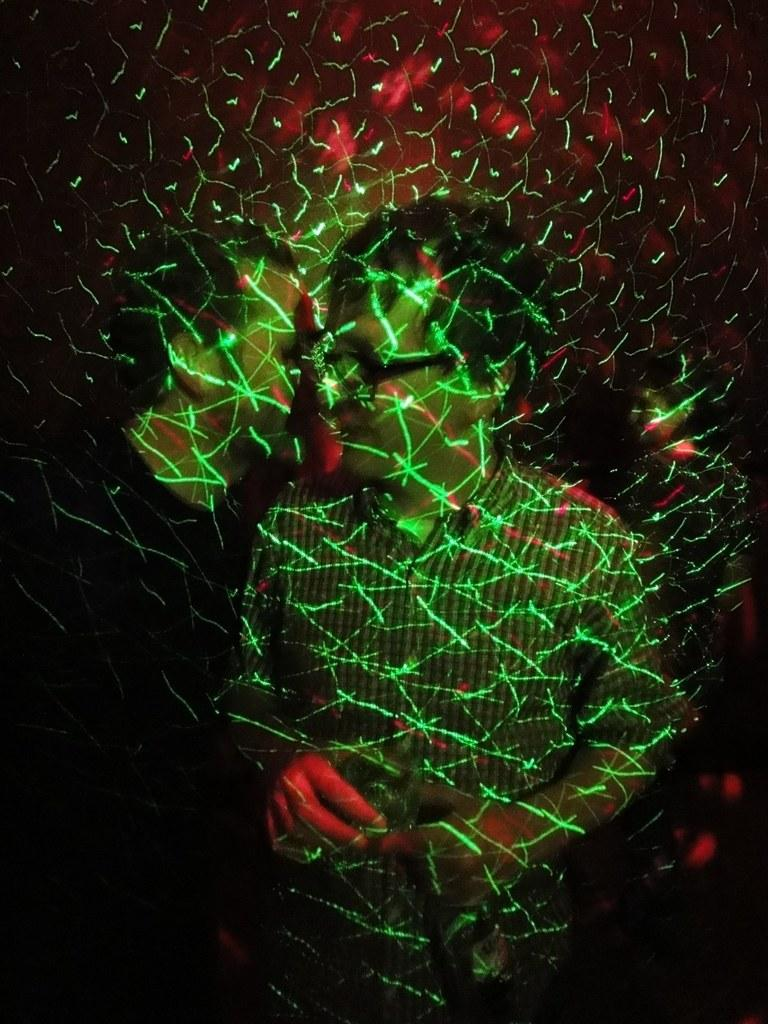Where was the image taken? The image is taken indoors. What can be seen in the background of the image? There is a wall in the background of the image. Who is the main subject in the image? A man is standing in the middle of the image. How many people are present in the image? There are a few people in the image. What type of camp can be seen in the background of the image? There is no camp present in the background of the image; it is a wall. What color is the sock worn by the man in the image? There is no sock visible on the man in the image. 